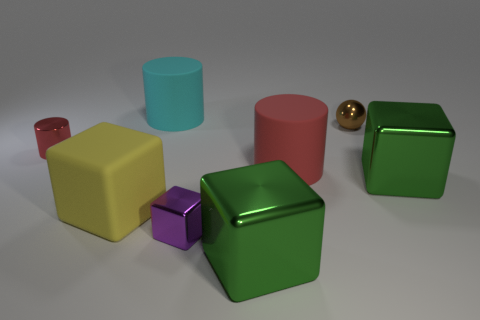There is a thing that is the same color as the small cylinder; what is its shape?
Keep it short and to the point. Cylinder. What number of gray objects are either tiny metal cubes or metal cylinders?
Keep it short and to the point. 0. What number of other objects are there of the same shape as the brown thing?
Ensure brevity in your answer.  0. Is the color of the matte cylinder in front of the large cyan thing the same as the large shiny cube that is left of the sphere?
Offer a terse response. No. How many big things are either metallic blocks or yellow blocks?
Offer a very short reply. 3. What is the size of the purple shiny object that is the same shape as the big yellow matte thing?
Offer a very short reply. Small. Are there any other things that have the same size as the matte block?
Give a very brief answer. Yes. There is a red cylinder left of the rubber cylinder behind the tiny red thing; what is its material?
Offer a very short reply. Metal. How many metallic objects are large yellow objects or small cylinders?
Keep it short and to the point. 1. What color is the big matte thing that is the same shape as the small purple thing?
Give a very brief answer. Yellow. 